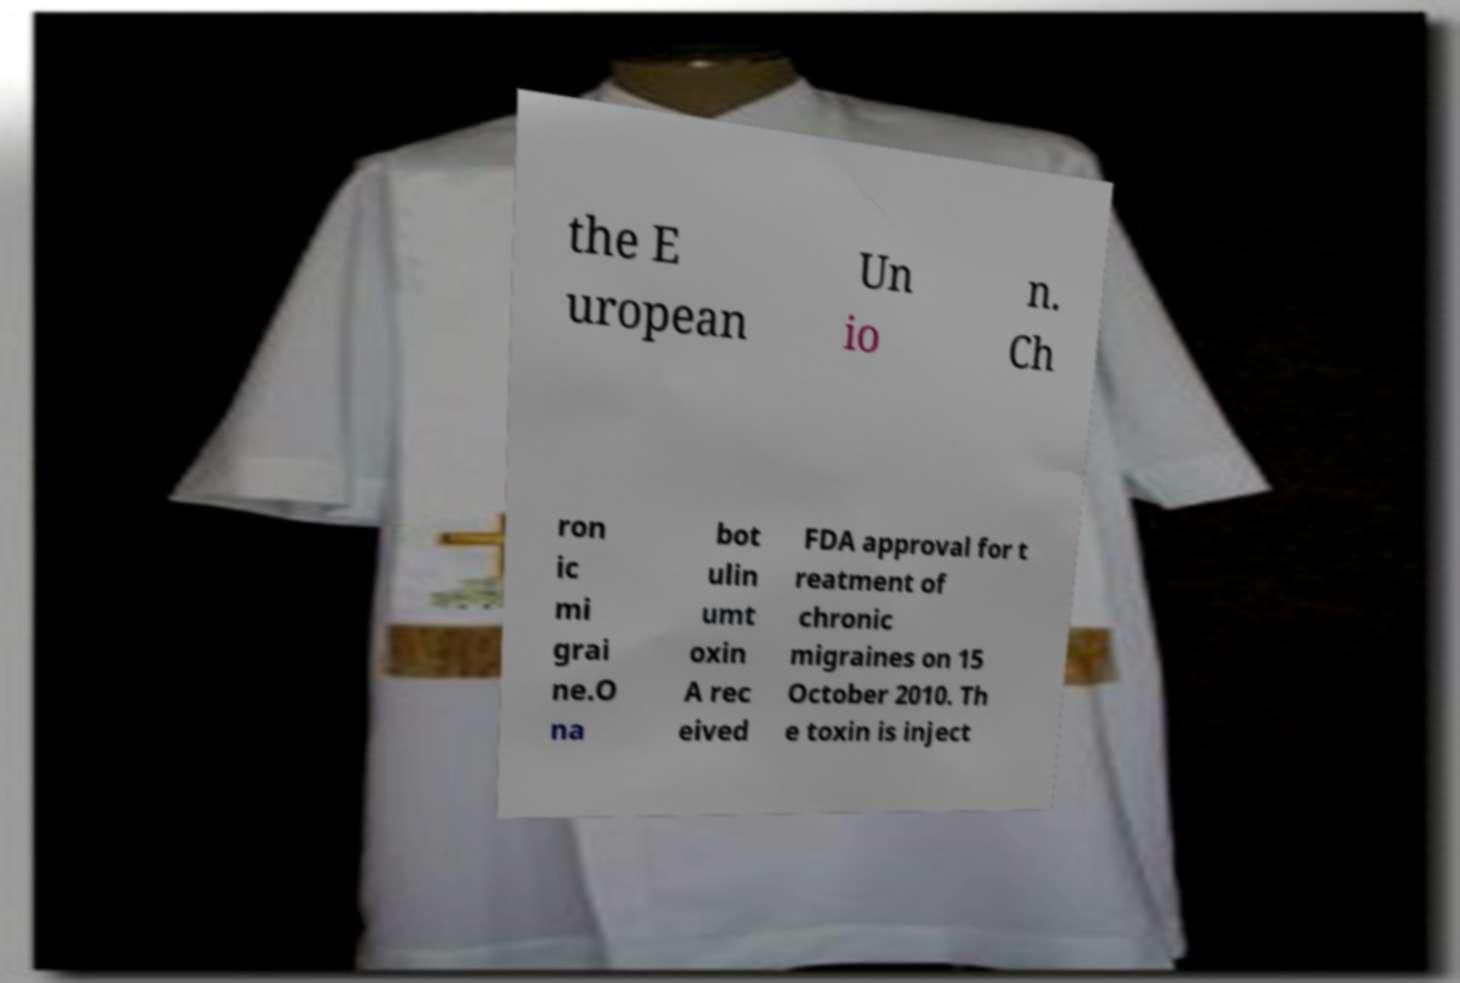Please identify and transcribe the text found in this image. the E uropean Un io n. Ch ron ic mi grai ne.O na bot ulin umt oxin A rec eived FDA approval for t reatment of chronic migraines on 15 October 2010. Th e toxin is inject 